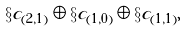<formula> <loc_0><loc_0><loc_500><loc_500>\S c _ { ( 2 , 1 ) } \oplus \S c _ { ( 1 , 0 ) } \oplus \S c _ { ( 1 , 1 ) } ,</formula> 